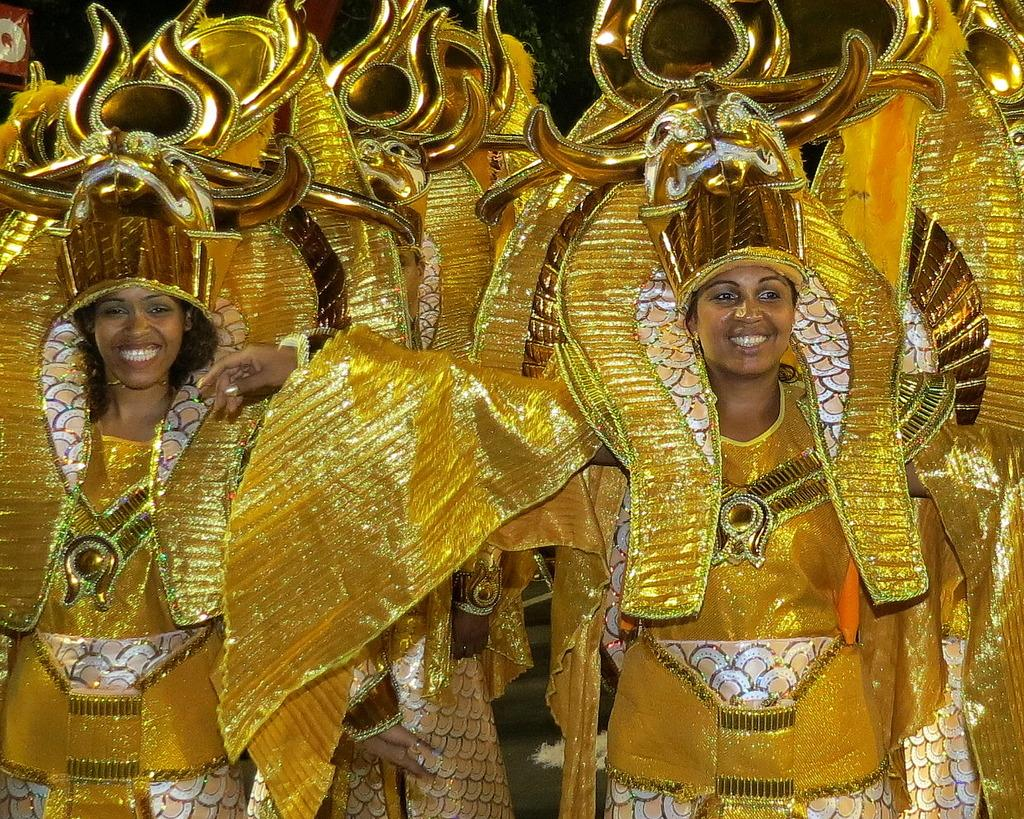Who is present in the image? There are girls in the image. What are the girls wearing? The girls are wearing gold-colored costumes. How are the girls positioned in the image? The girls are standing one beside the other. What type of support can be seen in the image? There is no support visible in the image; it features girls wearing gold-colored costumes and standing beside each other. Can you tell me how many sponges are being used by the girls in the image? There are no sponges present in the image. 